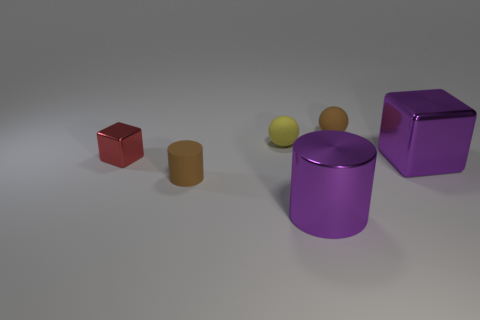Add 4 large cylinders. How many objects exist? 10 Subtract all balls. How many objects are left? 4 Subtract 0 red cylinders. How many objects are left? 6 Subtract all big green rubber cylinders. Subtract all metallic cubes. How many objects are left? 4 Add 4 brown rubber things. How many brown rubber things are left? 6 Add 4 large blue cylinders. How many large blue cylinders exist? 4 